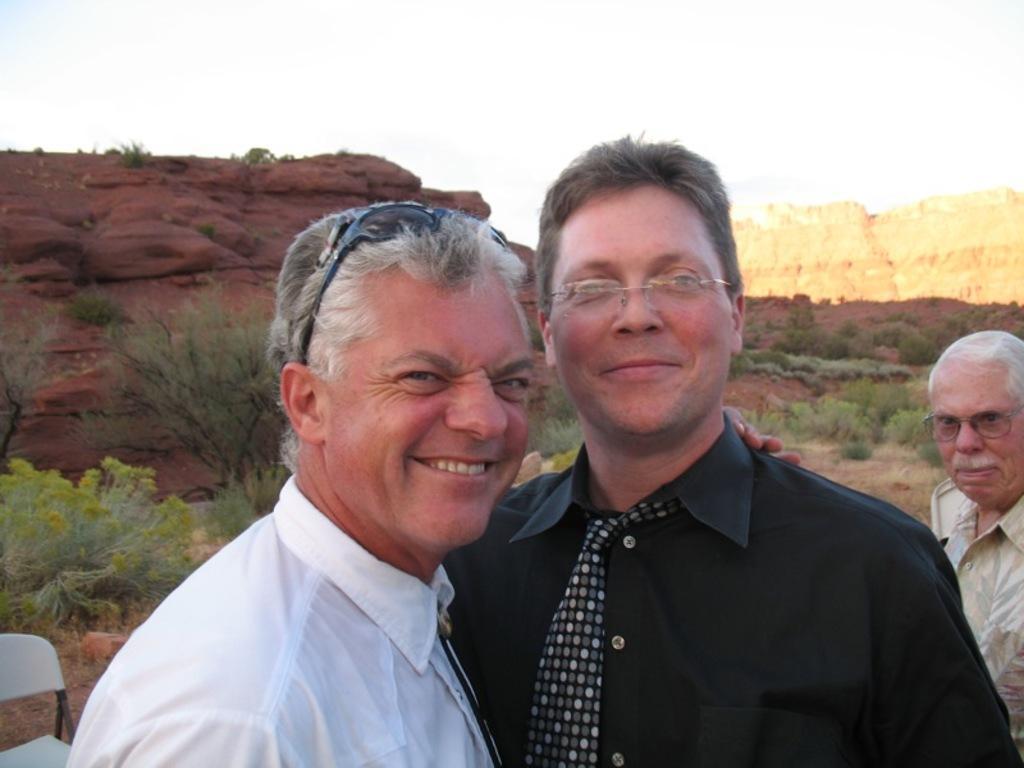Can you describe this image briefly? In front of the picture, we see two men are standing. They are smiling and they are posing for the photo. The man on the right side is wearing the spectacles. On the right side, we see a man is standing and he is wearing the spectacles. Behind him, we see the trees. In the left bottom, we see a white chair. In the background, we see the trees and the rocks. At the top, we see the sky and the clouds. 